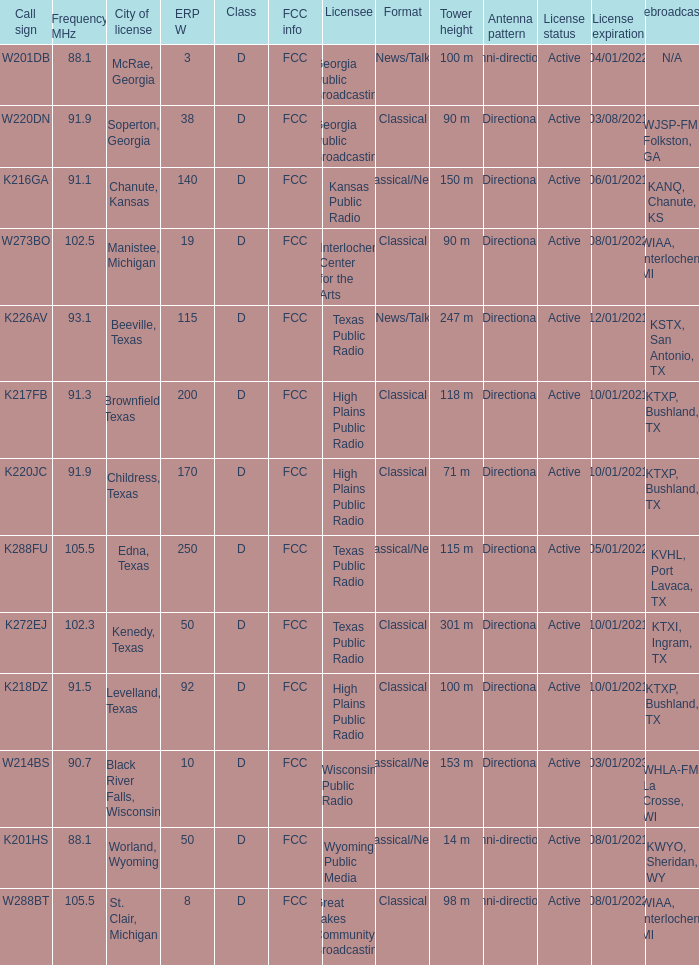What is City of License, when ERP W is greater than 3, and when Call Sign is K218DZ? Levelland, Texas. 